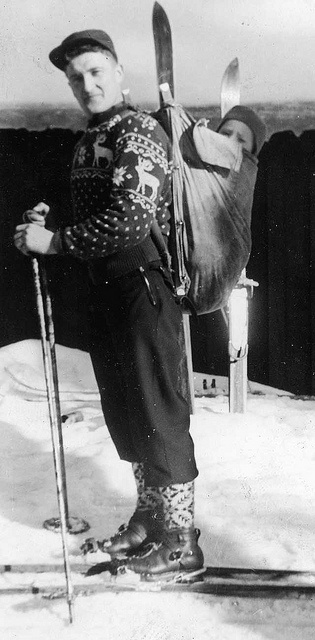Describe the objects in this image and their specific colors. I can see people in gainsboro, black, gray, darkgray, and lightgray tones, backpack in gainsboro, gray, darkgray, black, and lightgray tones, skis in gainsboro, lightgray, darkgray, gray, and black tones, skis in gainsboro, black, gray, darkgray, and lightgray tones, and skis in gainsboro, gray, lightgray, darkgray, and black tones in this image. 